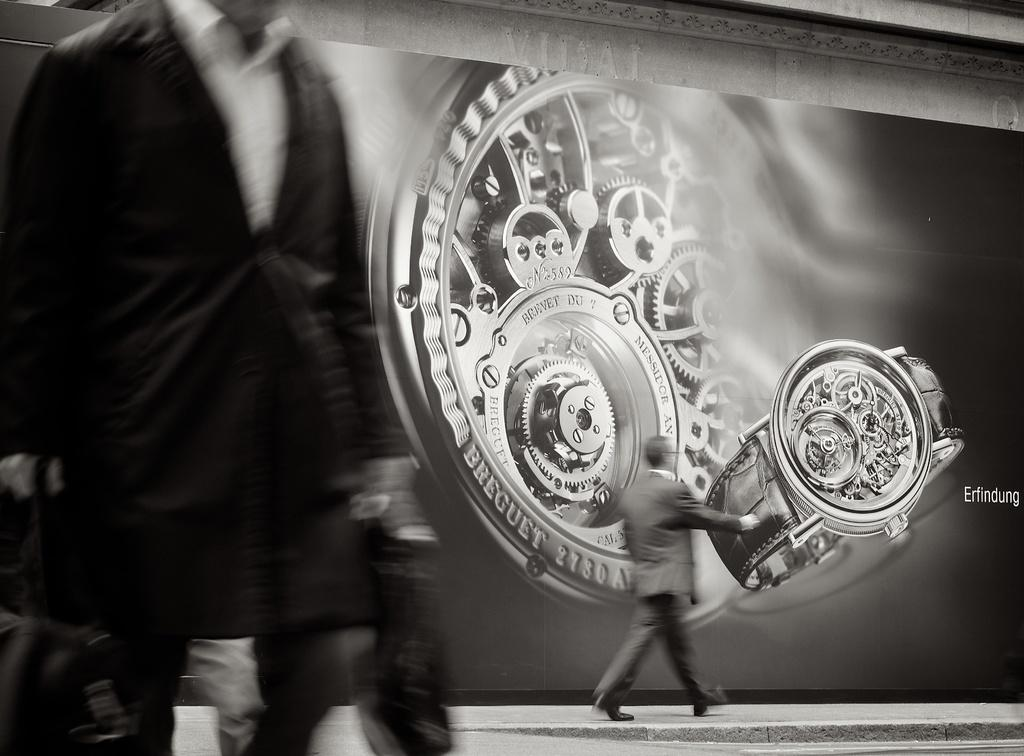<image>
Present a compact description of the photo's key features. A time piece is pictured on a background with men walking around with BREGUET BREVET DU 7 on it. 